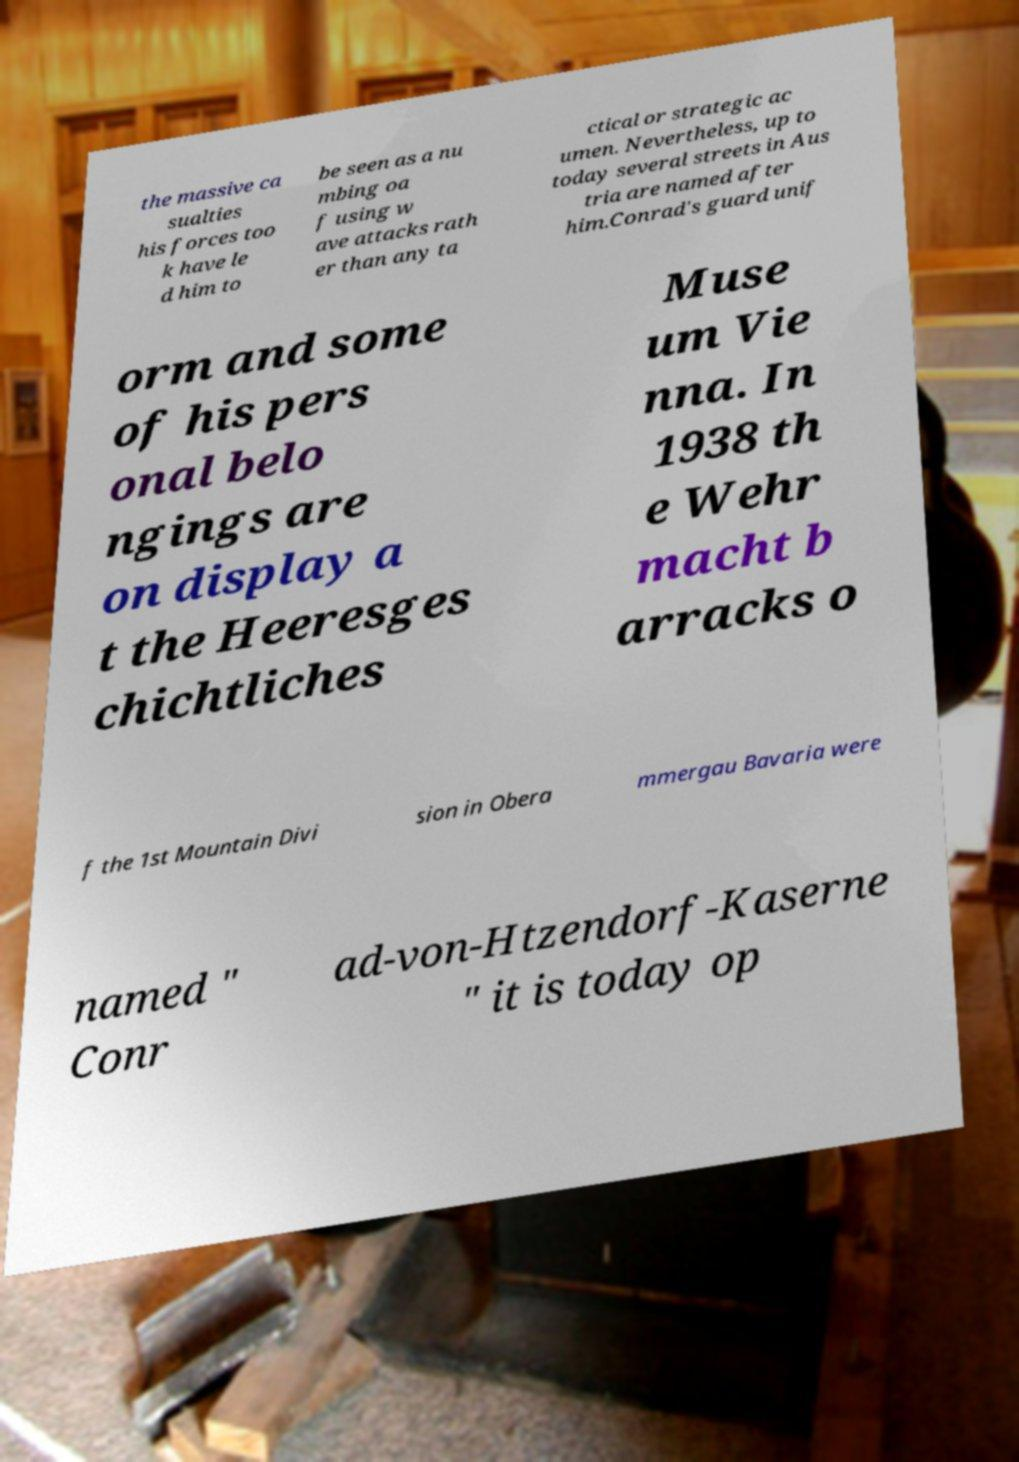Please identify and transcribe the text found in this image. the massive ca sualties his forces too k have le d him to be seen as a nu mbing oa f using w ave attacks rath er than any ta ctical or strategic ac umen. Nevertheless, up to today several streets in Aus tria are named after him.Conrad's guard unif orm and some of his pers onal belo ngings are on display a t the Heeresges chichtliches Muse um Vie nna. In 1938 th e Wehr macht b arracks o f the 1st Mountain Divi sion in Obera mmergau Bavaria were named " Conr ad-von-Htzendorf-Kaserne " it is today op 